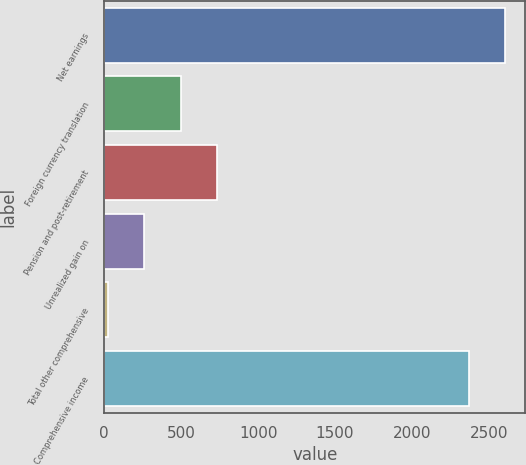<chart> <loc_0><loc_0><loc_500><loc_500><bar_chart><fcel>Net earnings<fcel>Foreign currency translation<fcel>Pension and post-retirement<fcel>Unrealized gain on<fcel>Total other comprehensive<fcel>Comprehensive income<nl><fcel>2606.89<fcel>496.28<fcel>733.27<fcel>259.29<fcel>22.3<fcel>2369.9<nl></chart> 